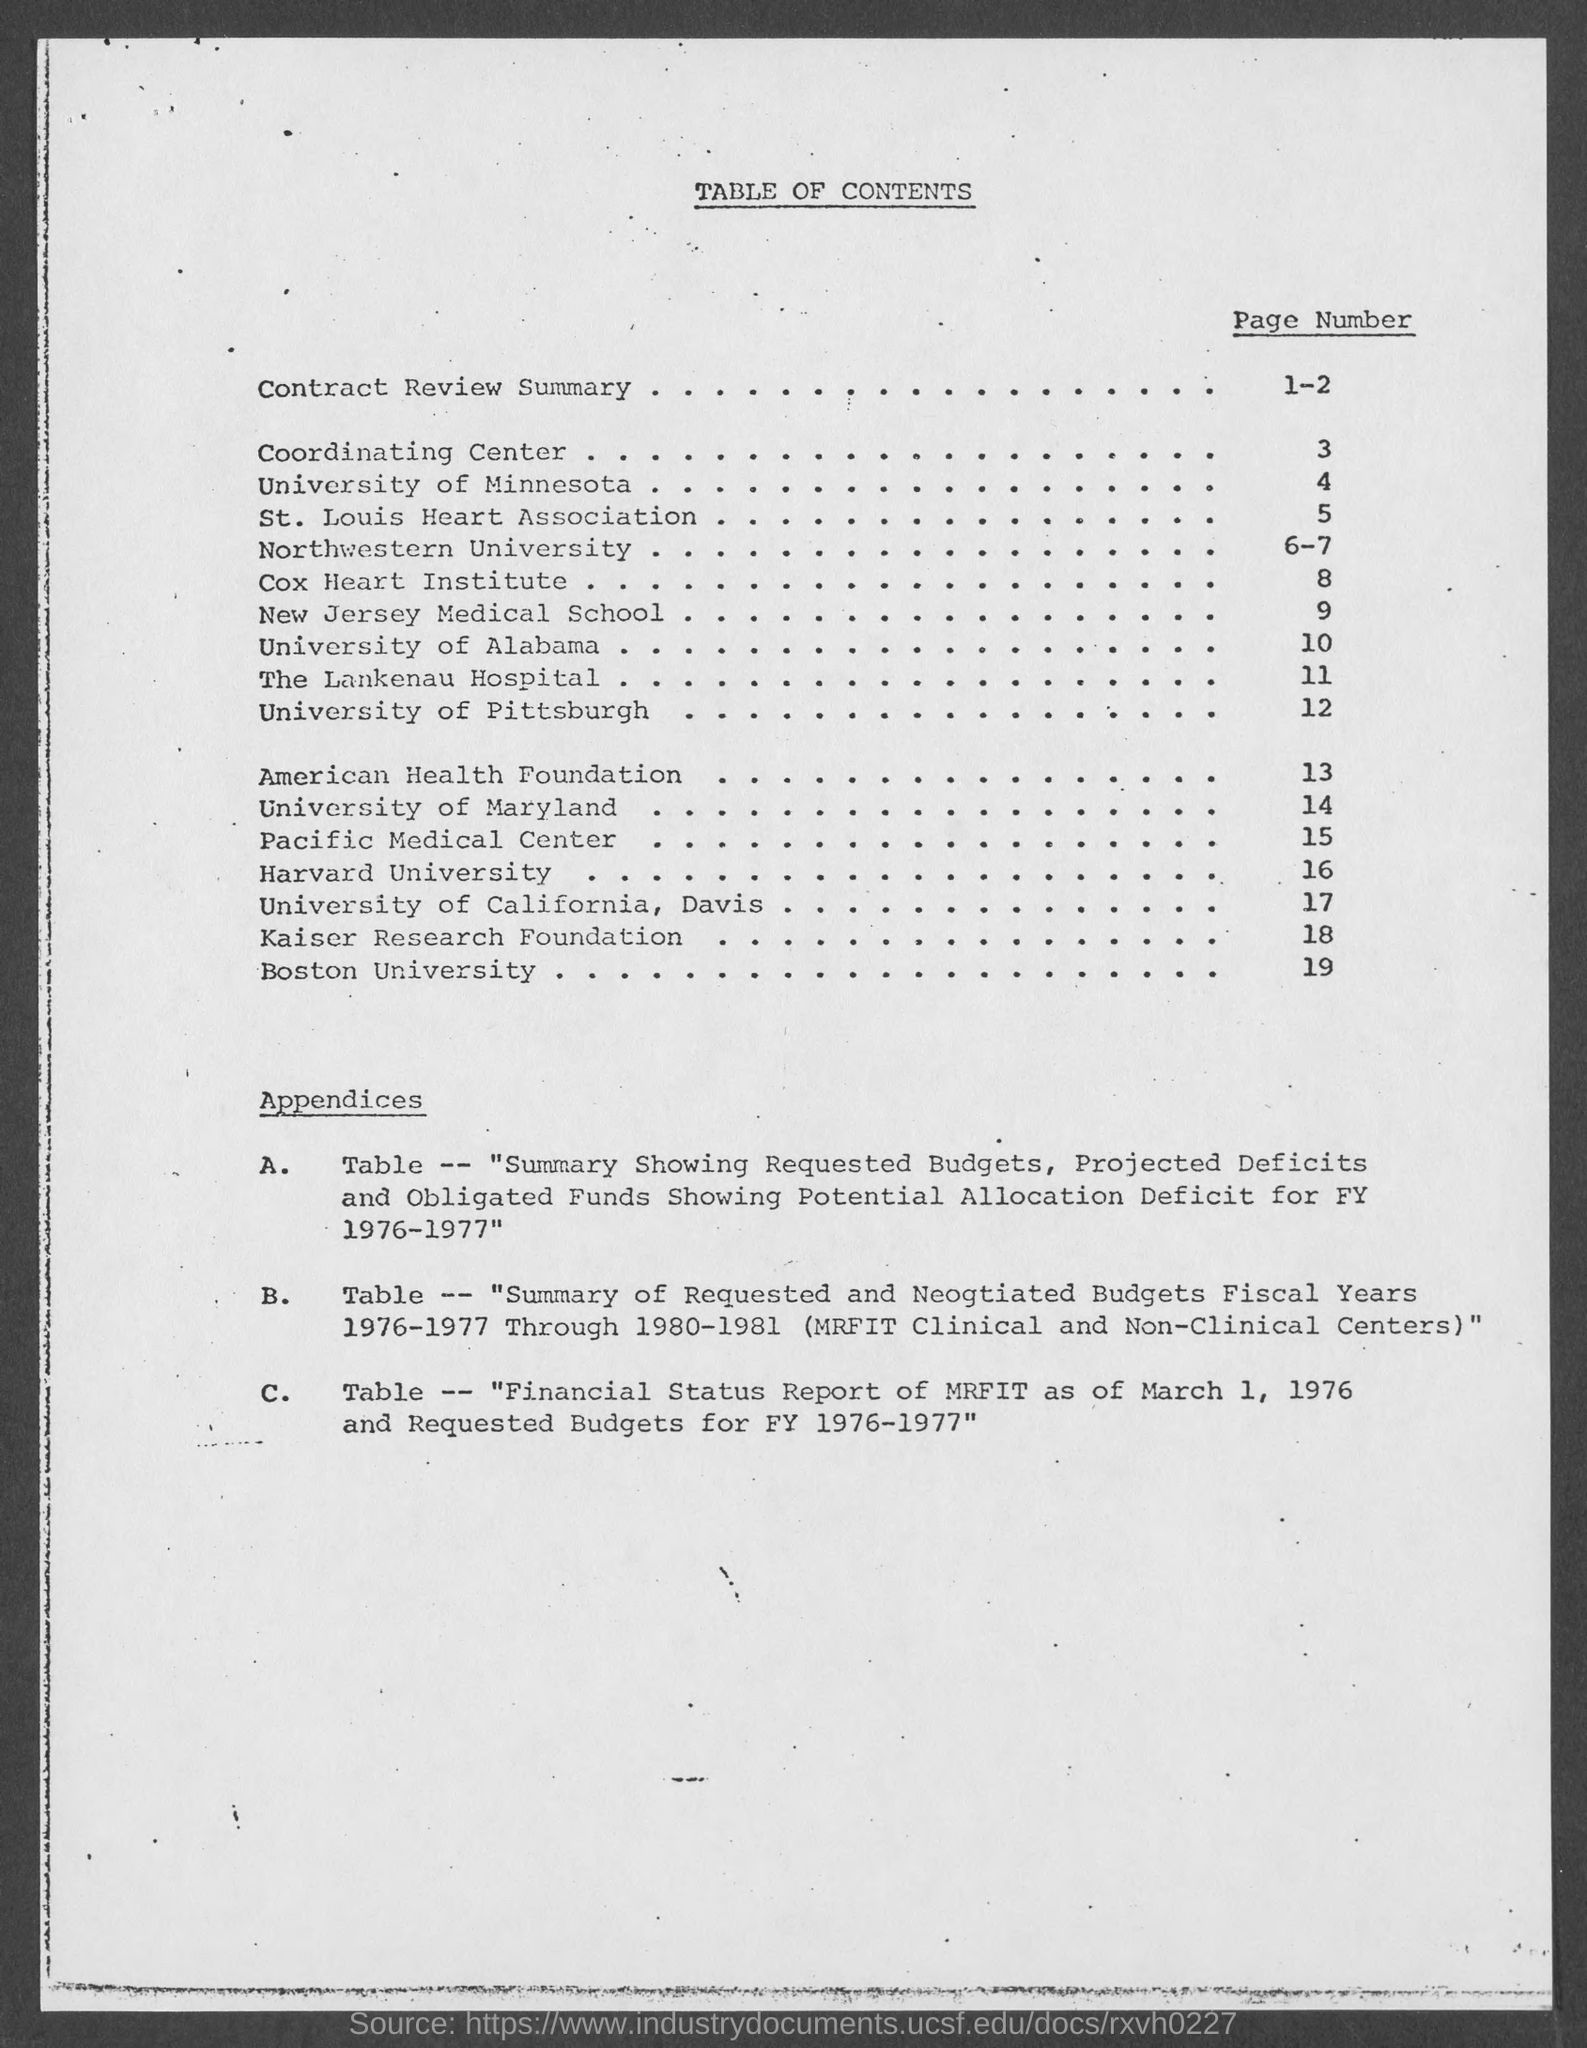What is the page number of contract review summary ?
Make the answer very short. 1-2. What is the title of document?
Offer a very short reply. Table of Contents. 